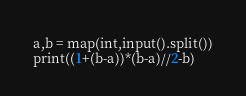<code> <loc_0><loc_0><loc_500><loc_500><_Python_>a,b = map(int,input().split())
print((1+(b-a))*(b-a)//2-b)</code> 